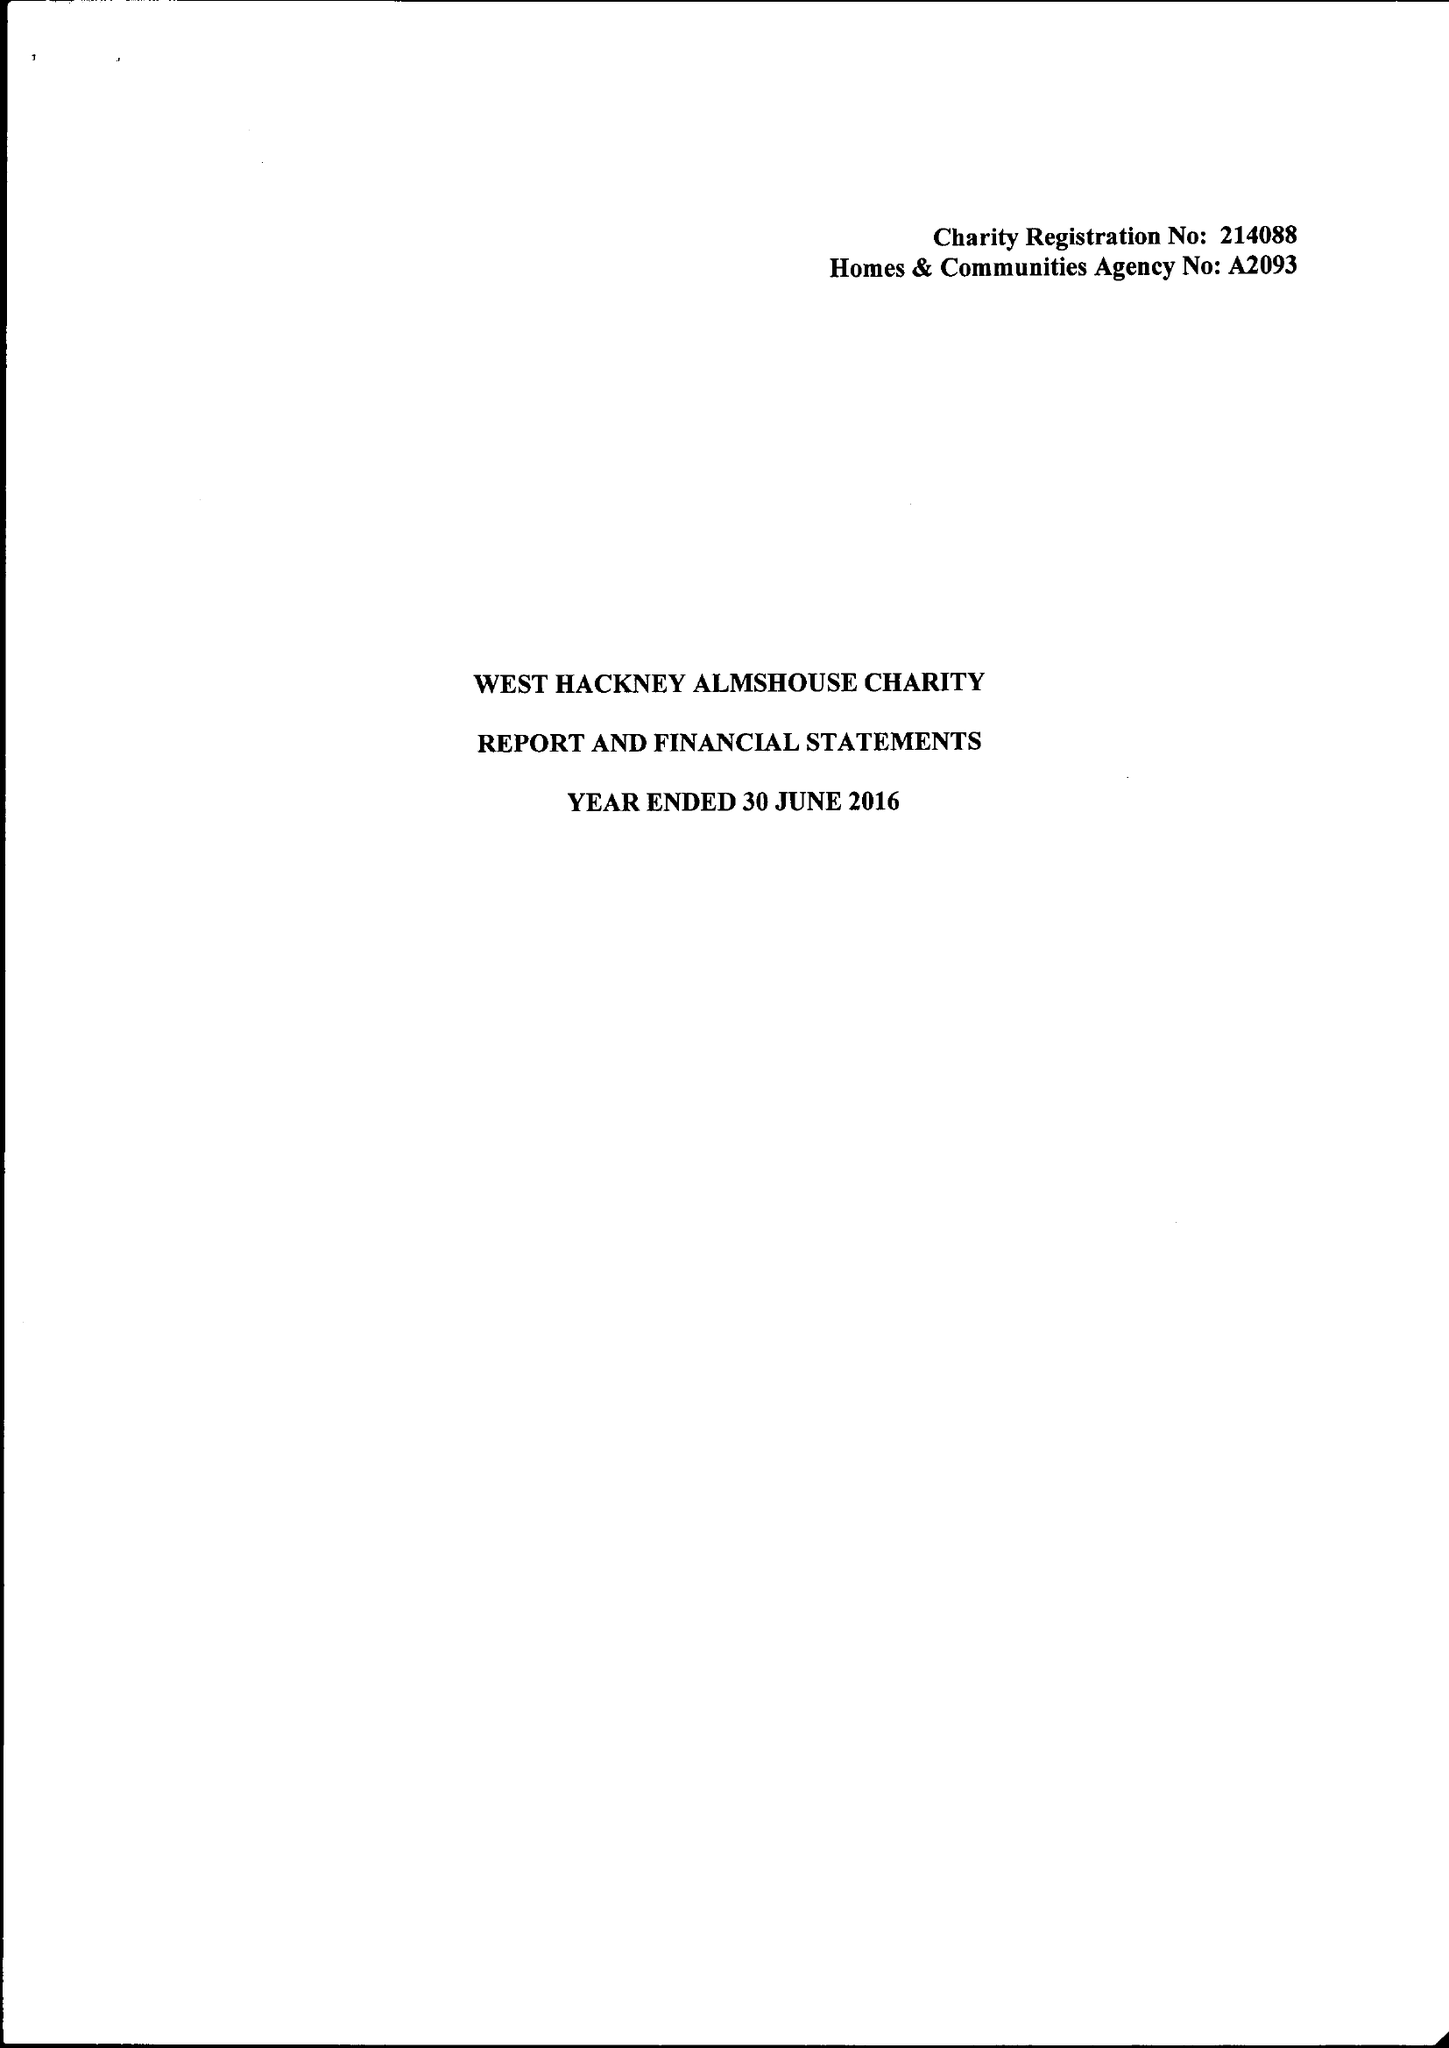What is the value for the address__street_line?
Answer the question using a single word or phrase. None 